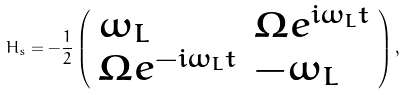<formula> <loc_0><loc_0><loc_500><loc_500>H _ { s } = - \frac { 1 } { 2 } \left ( \begin{array} { l l } \omega _ { L } & \Omega e ^ { i \omega _ { L } t } \\ \Omega e ^ { - i \omega _ { L } t } & - \omega _ { L } \end{array} \right ) ,</formula> 